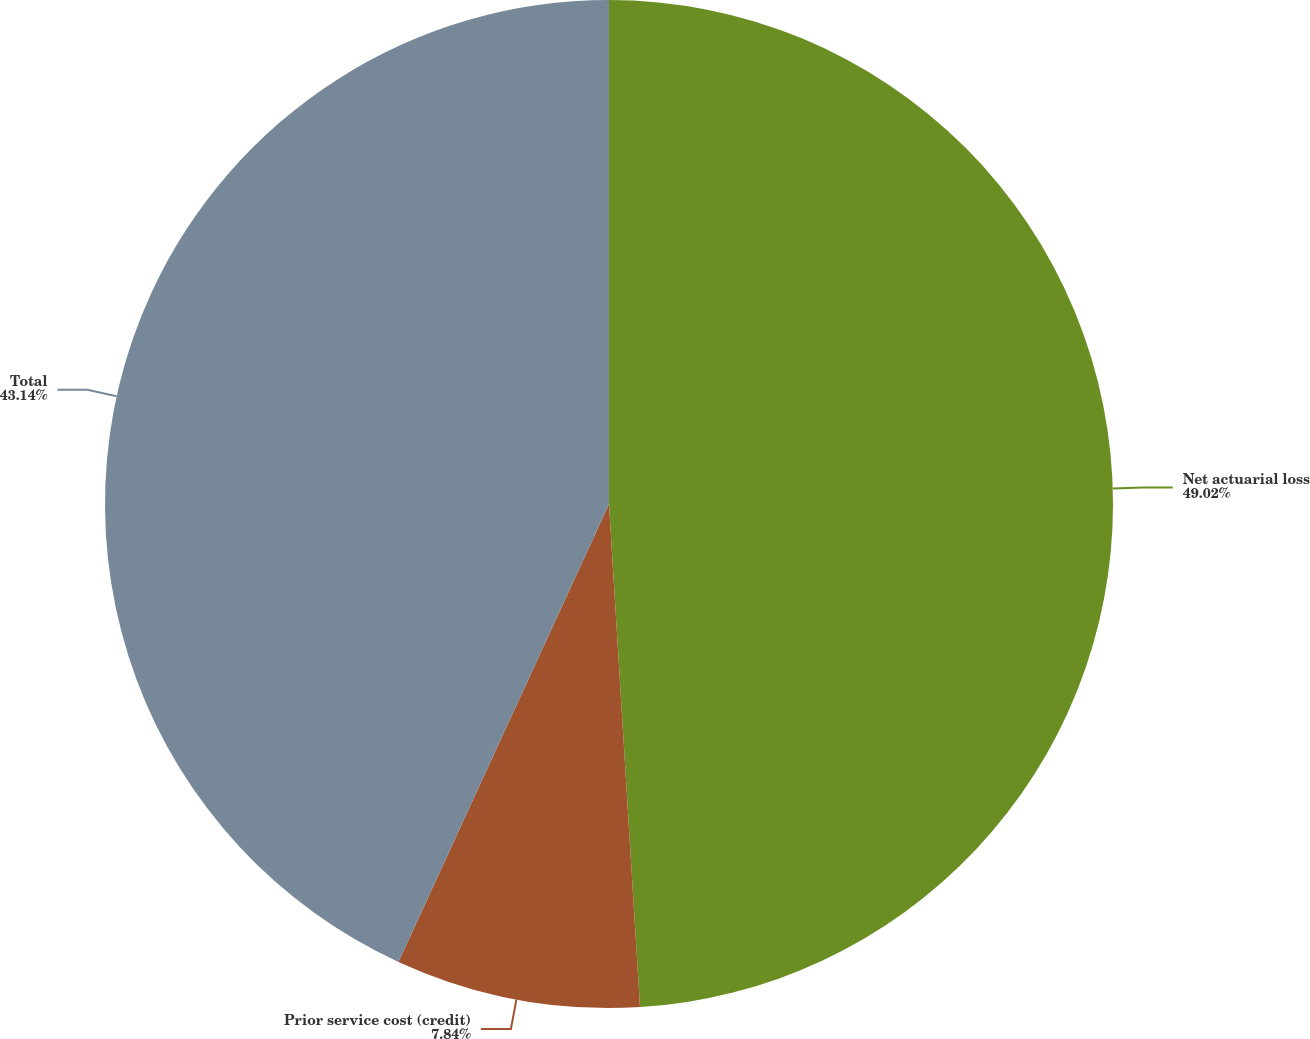Convert chart. <chart><loc_0><loc_0><loc_500><loc_500><pie_chart><fcel>Net actuarial loss<fcel>Prior service cost (credit)<fcel>Total<nl><fcel>49.02%<fcel>7.84%<fcel>43.14%<nl></chart> 